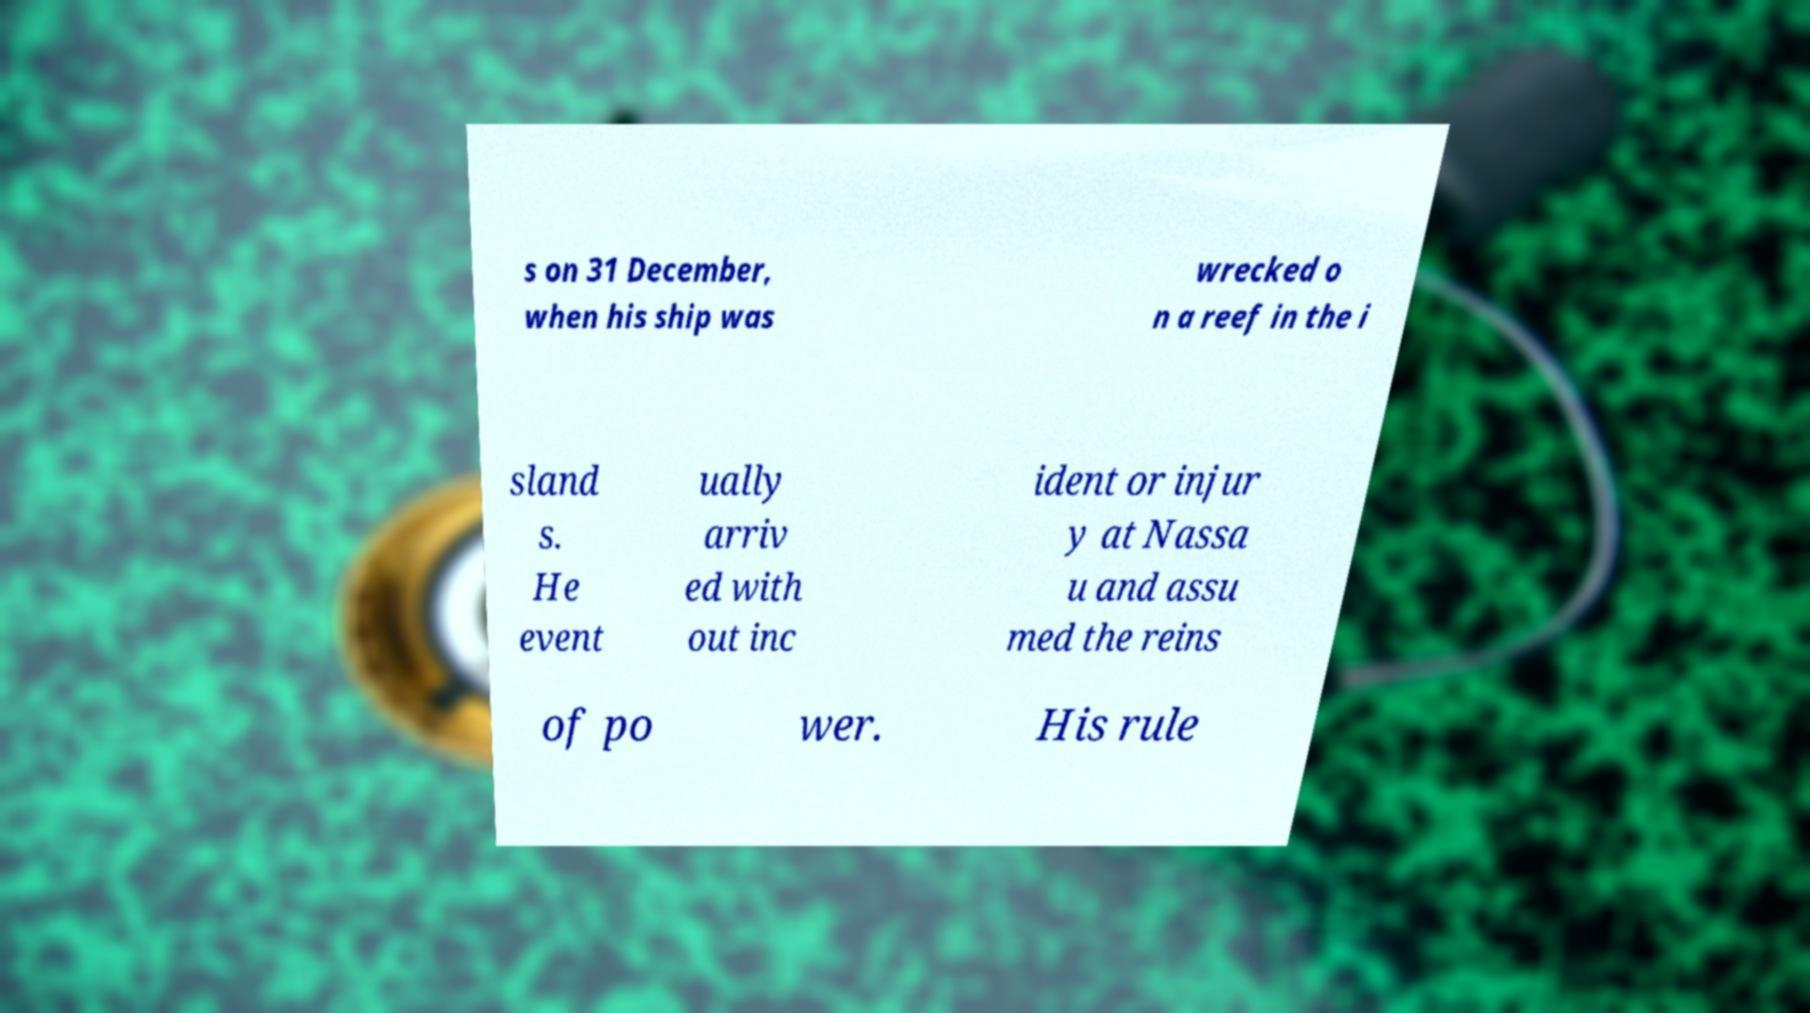Please read and relay the text visible in this image. What does it say? s on 31 December, when his ship was wrecked o n a reef in the i sland s. He event ually arriv ed with out inc ident or injur y at Nassa u and assu med the reins of po wer. His rule 